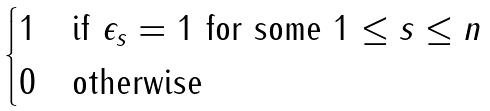<formula> <loc_0><loc_0><loc_500><loc_500>\begin{cases} 1 & \text {if $\epsilon_{s} = 1$ for some $1\leq s \leq n$} \\ 0 & \text {otherwise} \end{cases}</formula> 